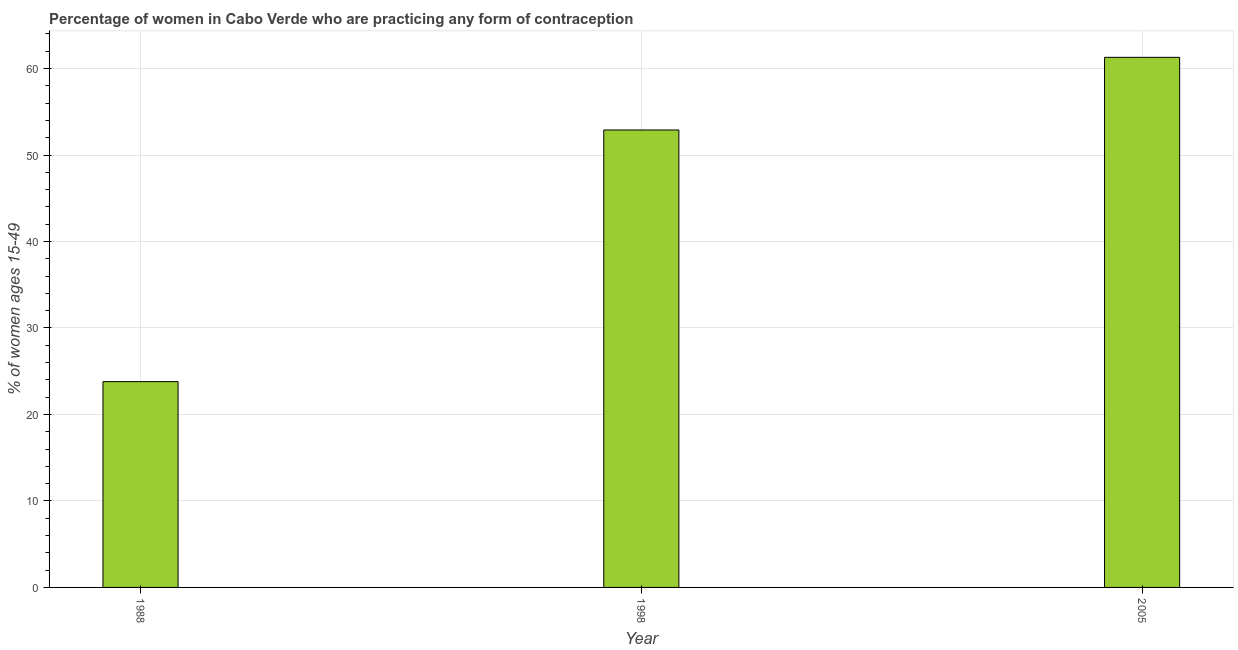What is the title of the graph?
Your answer should be very brief. Percentage of women in Cabo Verde who are practicing any form of contraception. What is the label or title of the Y-axis?
Ensure brevity in your answer.  % of women ages 15-49. What is the contraceptive prevalence in 1988?
Provide a short and direct response. 23.8. Across all years, what is the maximum contraceptive prevalence?
Your answer should be compact. 61.3. Across all years, what is the minimum contraceptive prevalence?
Your response must be concise. 23.8. In which year was the contraceptive prevalence minimum?
Make the answer very short. 1988. What is the sum of the contraceptive prevalence?
Provide a succinct answer. 138. What is the difference between the contraceptive prevalence in 1988 and 2005?
Offer a very short reply. -37.5. What is the median contraceptive prevalence?
Offer a very short reply. 52.9. What is the ratio of the contraceptive prevalence in 1988 to that in 2005?
Your answer should be compact. 0.39. Is the contraceptive prevalence in 1998 less than that in 2005?
Your response must be concise. Yes. Is the difference between the contraceptive prevalence in 1988 and 2005 greater than the difference between any two years?
Make the answer very short. Yes. What is the difference between the highest and the lowest contraceptive prevalence?
Your answer should be compact. 37.5. In how many years, is the contraceptive prevalence greater than the average contraceptive prevalence taken over all years?
Ensure brevity in your answer.  2. How many bars are there?
Your answer should be very brief. 3. Are all the bars in the graph horizontal?
Keep it short and to the point. No. Are the values on the major ticks of Y-axis written in scientific E-notation?
Your answer should be compact. No. What is the % of women ages 15-49 of 1988?
Your response must be concise. 23.8. What is the % of women ages 15-49 of 1998?
Your answer should be very brief. 52.9. What is the % of women ages 15-49 of 2005?
Keep it short and to the point. 61.3. What is the difference between the % of women ages 15-49 in 1988 and 1998?
Provide a succinct answer. -29.1. What is the difference between the % of women ages 15-49 in 1988 and 2005?
Make the answer very short. -37.5. What is the difference between the % of women ages 15-49 in 1998 and 2005?
Ensure brevity in your answer.  -8.4. What is the ratio of the % of women ages 15-49 in 1988 to that in 1998?
Your answer should be very brief. 0.45. What is the ratio of the % of women ages 15-49 in 1988 to that in 2005?
Ensure brevity in your answer.  0.39. What is the ratio of the % of women ages 15-49 in 1998 to that in 2005?
Your response must be concise. 0.86. 